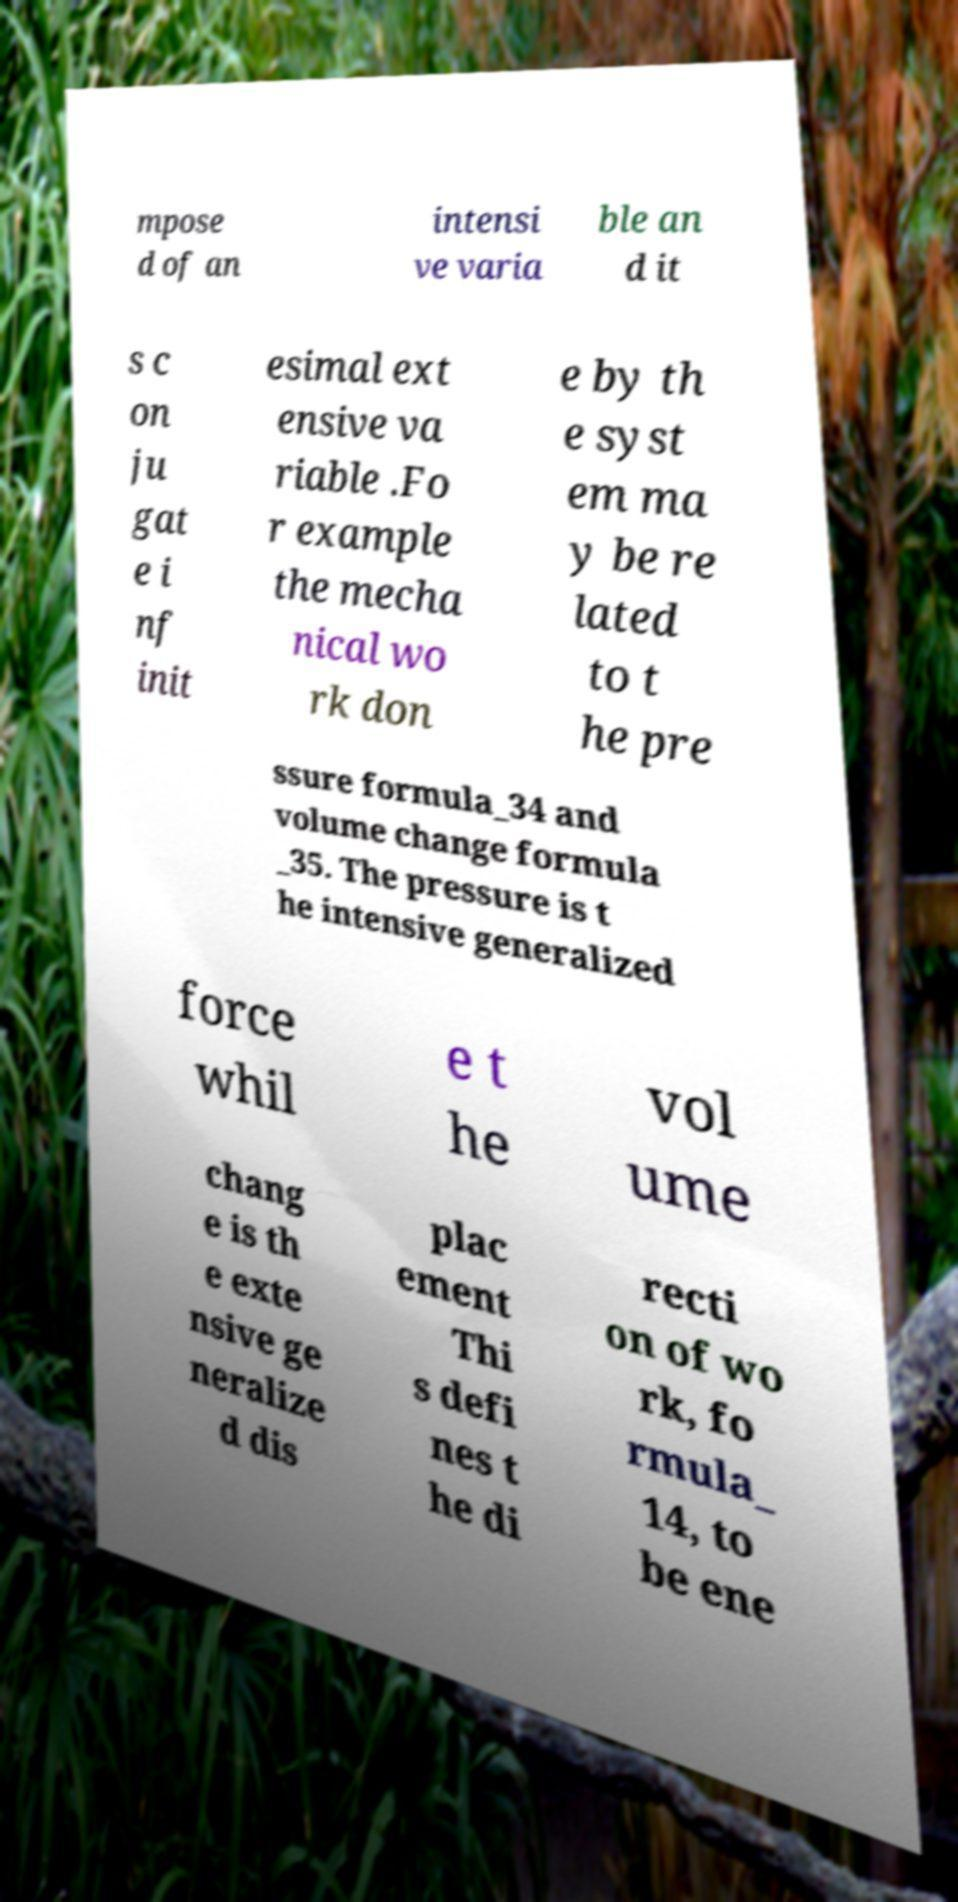Can you read and provide the text displayed in the image?This photo seems to have some interesting text. Can you extract and type it out for me? mpose d of an intensi ve varia ble an d it s c on ju gat e i nf init esimal ext ensive va riable .Fo r example the mecha nical wo rk don e by th e syst em ma y be re lated to t he pre ssure formula_34 and volume change formula _35. The pressure is t he intensive generalized force whil e t he vol ume chang e is th e exte nsive ge neralize d dis plac ement Thi s defi nes t he di recti on of wo rk, fo rmula_ 14, to be ene 